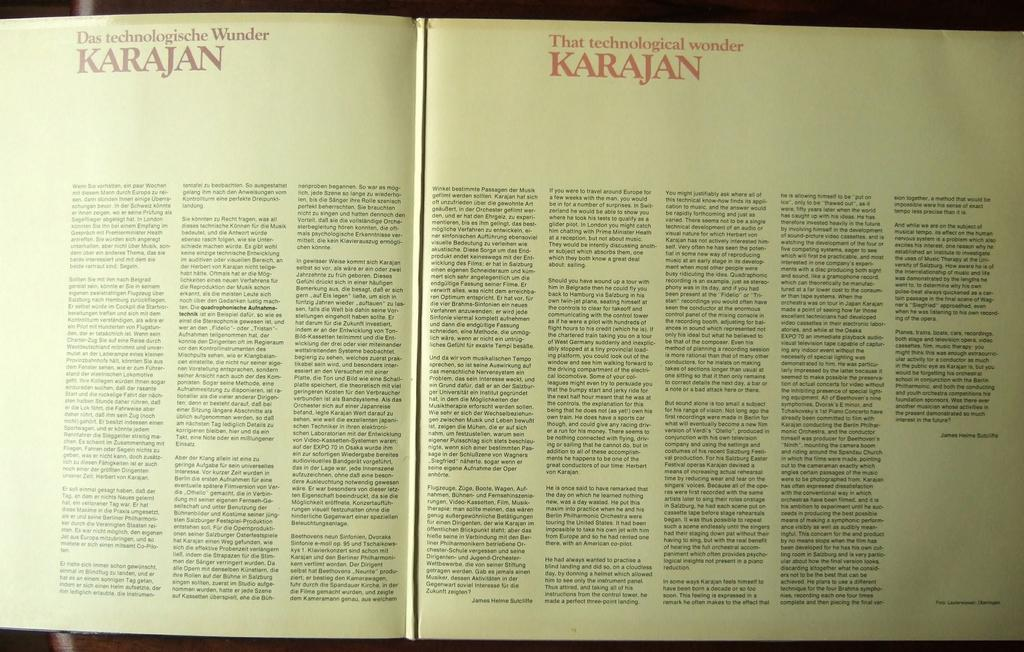<image>
Share a concise interpretation of the image provided. An open book describing the wonderful Karajan technology. 